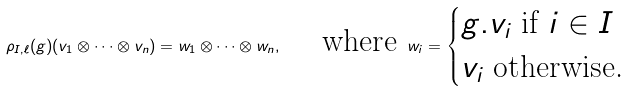Convert formula to latex. <formula><loc_0><loc_0><loc_500><loc_500>\rho _ { I , \ell } ( g ) ( v _ { 1 } \otimes \dots \otimes v _ { n } ) = w _ { 1 } \otimes \dots \otimes w _ { n } , \quad \text { where } w _ { i } = \begin{cases} g . v _ { i } \text { if } i \in I \\ v _ { i } \text { otherwise.} \end{cases}</formula> 